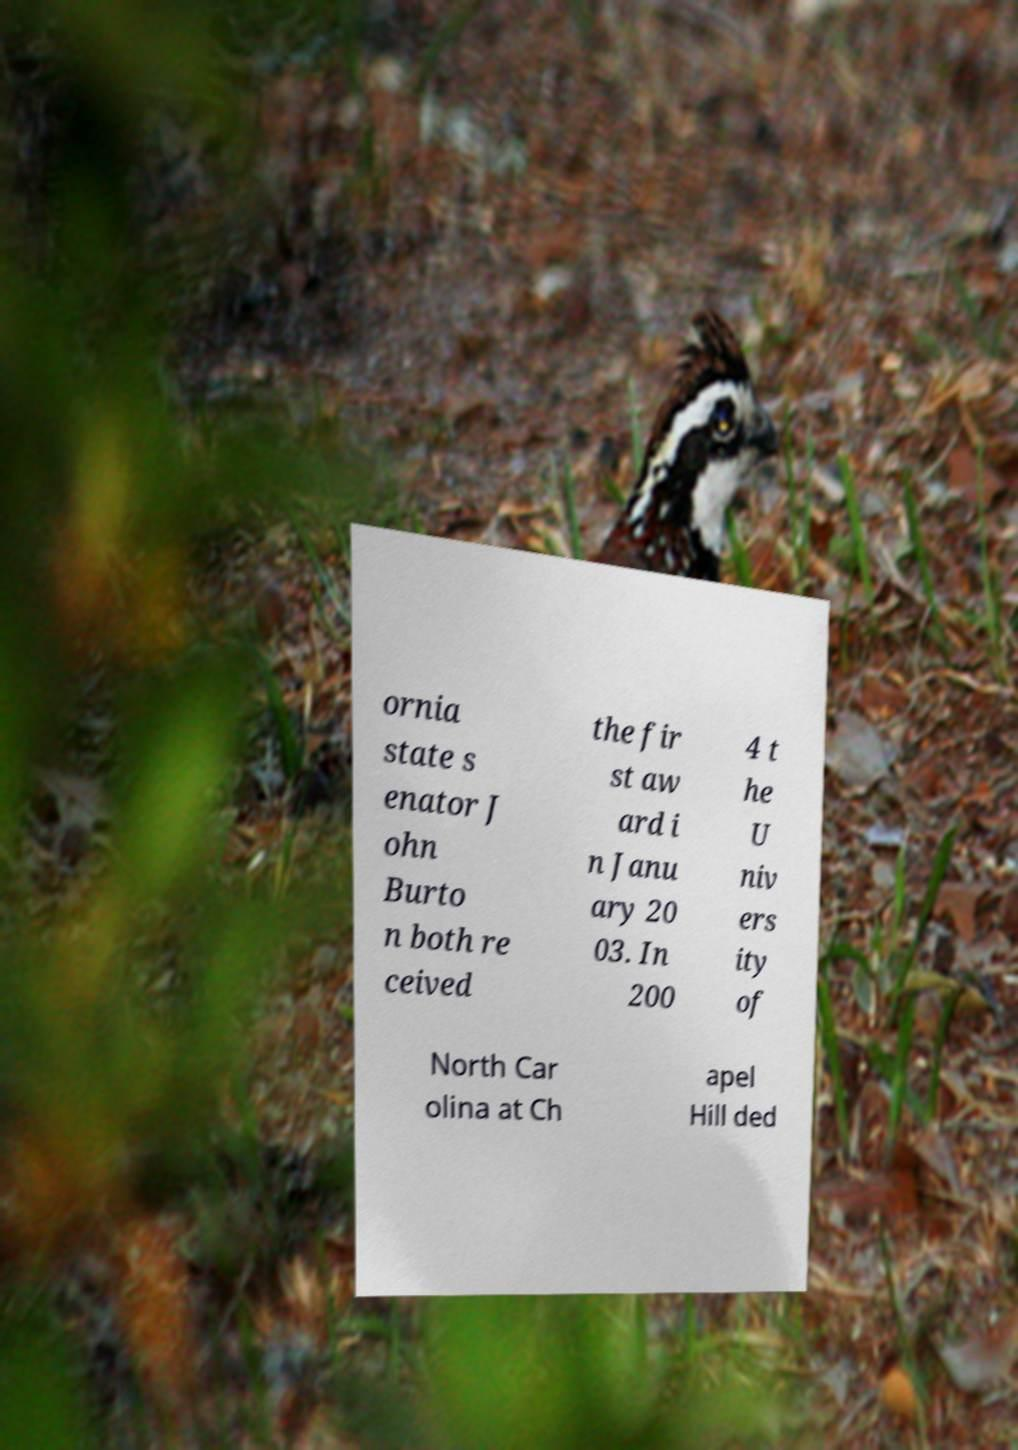I need the written content from this picture converted into text. Can you do that? ornia state s enator J ohn Burto n both re ceived the fir st aw ard i n Janu ary 20 03. In 200 4 t he U niv ers ity of North Car olina at Ch apel Hill ded 